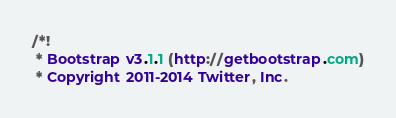<code> <loc_0><loc_0><loc_500><loc_500><_CSS_>/*!
 * Bootstrap v3.1.1 (http://getbootstrap.com)
 * Copyright 2011-2014 Twitter, Inc.</code> 